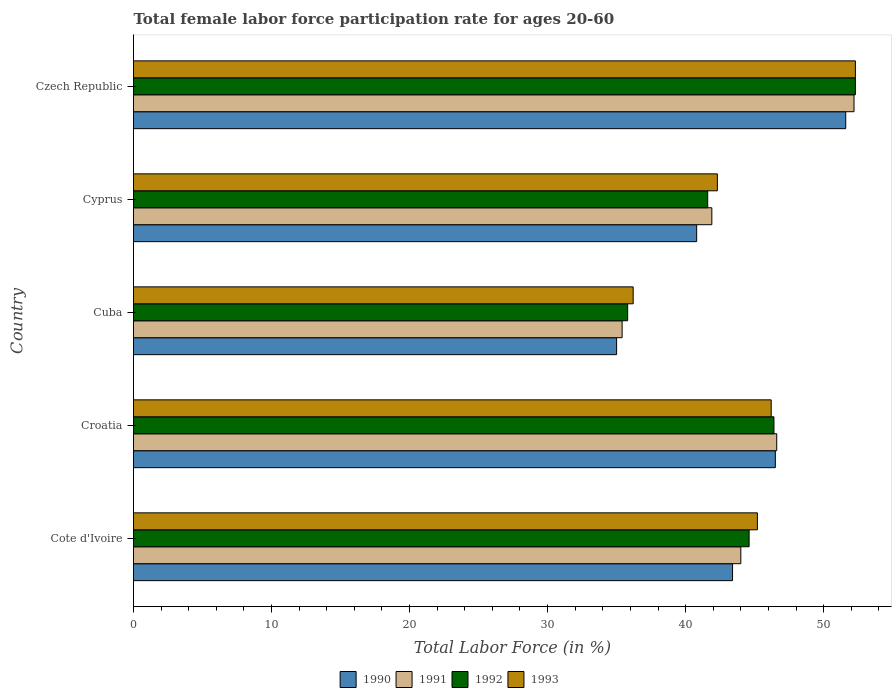How many different coloured bars are there?
Your answer should be compact. 4. How many groups of bars are there?
Give a very brief answer. 5. Are the number of bars on each tick of the Y-axis equal?
Your answer should be compact. Yes. How many bars are there on the 3rd tick from the bottom?
Give a very brief answer. 4. What is the label of the 3rd group of bars from the top?
Give a very brief answer. Cuba. In how many cases, is the number of bars for a given country not equal to the number of legend labels?
Your answer should be compact. 0. What is the female labor force participation rate in 1993 in Croatia?
Provide a succinct answer. 46.2. Across all countries, what is the maximum female labor force participation rate in 1993?
Ensure brevity in your answer.  52.3. Across all countries, what is the minimum female labor force participation rate in 1992?
Your response must be concise. 35.8. In which country was the female labor force participation rate in 1991 maximum?
Provide a succinct answer. Czech Republic. In which country was the female labor force participation rate in 1992 minimum?
Ensure brevity in your answer.  Cuba. What is the total female labor force participation rate in 1991 in the graph?
Your answer should be very brief. 220.1. What is the difference between the female labor force participation rate in 1991 in Cyprus and that in Czech Republic?
Offer a very short reply. -10.3. What is the difference between the female labor force participation rate in 1991 in Croatia and the female labor force participation rate in 1993 in Czech Republic?
Give a very brief answer. -5.7. What is the average female labor force participation rate in 1992 per country?
Provide a succinct answer. 44.14. What is the difference between the female labor force participation rate in 1993 and female labor force participation rate in 1990 in Croatia?
Offer a very short reply. -0.3. What is the ratio of the female labor force participation rate in 1993 in Cyprus to that in Czech Republic?
Give a very brief answer. 0.81. Is the female labor force participation rate in 1991 in Cuba less than that in Cyprus?
Keep it short and to the point. Yes. Is the difference between the female labor force participation rate in 1993 in Cote d'Ivoire and Cuba greater than the difference between the female labor force participation rate in 1990 in Cote d'Ivoire and Cuba?
Make the answer very short. Yes. What is the difference between the highest and the second highest female labor force participation rate in 1993?
Provide a succinct answer. 6.1. What is the difference between the highest and the lowest female labor force participation rate in 1993?
Your answer should be compact. 16.1. Is the sum of the female labor force participation rate in 1991 in Cyprus and Czech Republic greater than the maximum female labor force participation rate in 1993 across all countries?
Give a very brief answer. Yes. Is it the case that in every country, the sum of the female labor force participation rate in 1992 and female labor force participation rate in 1990 is greater than the sum of female labor force participation rate in 1991 and female labor force participation rate in 1993?
Your response must be concise. No. What does the 2nd bar from the bottom in Cyprus represents?
Provide a succinct answer. 1991. Is it the case that in every country, the sum of the female labor force participation rate in 1993 and female labor force participation rate in 1990 is greater than the female labor force participation rate in 1992?
Your response must be concise. Yes. How many bars are there?
Provide a succinct answer. 20. Are all the bars in the graph horizontal?
Keep it short and to the point. Yes. How many countries are there in the graph?
Provide a succinct answer. 5. What is the difference between two consecutive major ticks on the X-axis?
Your answer should be very brief. 10. Are the values on the major ticks of X-axis written in scientific E-notation?
Offer a very short reply. No. Does the graph contain grids?
Your response must be concise. No. Where does the legend appear in the graph?
Your answer should be very brief. Bottom center. How many legend labels are there?
Your answer should be compact. 4. How are the legend labels stacked?
Offer a terse response. Horizontal. What is the title of the graph?
Offer a terse response. Total female labor force participation rate for ages 20-60. What is the Total Labor Force (in %) of 1990 in Cote d'Ivoire?
Your answer should be compact. 43.4. What is the Total Labor Force (in %) in 1991 in Cote d'Ivoire?
Offer a terse response. 44. What is the Total Labor Force (in %) of 1992 in Cote d'Ivoire?
Your answer should be compact. 44.6. What is the Total Labor Force (in %) of 1993 in Cote d'Ivoire?
Give a very brief answer. 45.2. What is the Total Labor Force (in %) in 1990 in Croatia?
Ensure brevity in your answer.  46.5. What is the Total Labor Force (in %) of 1991 in Croatia?
Provide a succinct answer. 46.6. What is the Total Labor Force (in %) in 1992 in Croatia?
Ensure brevity in your answer.  46.4. What is the Total Labor Force (in %) of 1993 in Croatia?
Keep it short and to the point. 46.2. What is the Total Labor Force (in %) in 1990 in Cuba?
Your response must be concise. 35. What is the Total Labor Force (in %) in 1991 in Cuba?
Your answer should be compact. 35.4. What is the Total Labor Force (in %) in 1992 in Cuba?
Give a very brief answer. 35.8. What is the Total Labor Force (in %) in 1993 in Cuba?
Provide a short and direct response. 36.2. What is the Total Labor Force (in %) in 1990 in Cyprus?
Make the answer very short. 40.8. What is the Total Labor Force (in %) of 1991 in Cyprus?
Make the answer very short. 41.9. What is the Total Labor Force (in %) of 1992 in Cyprus?
Provide a short and direct response. 41.6. What is the Total Labor Force (in %) in 1993 in Cyprus?
Your response must be concise. 42.3. What is the Total Labor Force (in %) of 1990 in Czech Republic?
Your response must be concise. 51.6. What is the Total Labor Force (in %) in 1991 in Czech Republic?
Offer a very short reply. 52.2. What is the Total Labor Force (in %) of 1992 in Czech Republic?
Make the answer very short. 52.3. What is the Total Labor Force (in %) of 1993 in Czech Republic?
Keep it short and to the point. 52.3. Across all countries, what is the maximum Total Labor Force (in %) in 1990?
Make the answer very short. 51.6. Across all countries, what is the maximum Total Labor Force (in %) of 1991?
Give a very brief answer. 52.2. Across all countries, what is the maximum Total Labor Force (in %) in 1992?
Make the answer very short. 52.3. Across all countries, what is the maximum Total Labor Force (in %) in 1993?
Provide a short and direct response. 52.3. Across all countries, what is the minimum Total Labor Force (in %) of 1990?
Offer a terse response. 35. Across all countries, what is the minimum Total Labor Force (in %) in 1991?
Offer a very short reply. 35.4. Across all countries, what is the minimum Total Labor Force (in %) in 1992?
Offer a terse response. 35.8. Across all countries, what is the minimum Total Labor Force (in %) in 1993?
Your answer should be compact. 36.2. What is the total Total Labor Force (in %) in 1990 in the graph?
Keep it short and to the point. 217.3. What is the total Total Labor Force (in %) in 1991 in the graph?
Make the answer very short. 220.1. What is the total Total Labor Force (in %) of 1992 in the graph?
Give a very brief answer. 220.7. What is the total Total Labor Force (in %) in 1993 in the graph?
Provide a succinct answer. 222.2. What is the difference between the Total Labor Force (in %) of 1990 in Cote d'Ivoire and that in Croatia?
Ensure brevity in your answer.  -3.1. What is the difference between the Total Labor Force (in %) of 1991 in Cote d'Ivoire and that in Croatia?
Offer a terse response. -2.6. What is the difference between the Total Labor Force (in %) of 1992 in Cote d'Ivoire and that in Croatia?
Offer a very short reply. -1.8. What is the difference between the Total Labor Force (in %) in 1993 in Cote d'Ivoire and that in Croatia?
Offer a terse response. -1. What is the difference between the Total Labor Force (in %) in 1991 in Cote d'Ivoire and that in Cuba?
Give a very brief answer. 8.6. What is the difference between the Total Labor Force (in %) of 1993 in Cote d'Ivoire and that in Cuba?
Provide a short and direct response. 9. What is the difference between the Total Labor Force (in %) in 1990 in Cote d'Ivoire and that in Cyprus?
Your response must be concise. 2.6. What is the difference between the Total Labor Force (in %) of 1990 in Cote d'Ivoire and that in Czech Republic?
Keep it short and to the point. -8.2. What is the difference between the Total Labor Force (in %) in 1991 in Cote d'Ivoire and that in Czech Republic?
Your answer should be compact. -8.2. What is the difference between the Total Labor Force (in %) in 1991 in Croatia and that in Cuba?
Your answer should be compact. 11.2. What is the difference between the Total Labor Force (in %) of 1993 in Croatia and that in Cuba?
Your answer should be compact. 10. What is the difference between the Total Labor Force (in %) of 1990 in Croatia and that in Cyprus?
Provide a short and direct response. 5.7. What is the difference between the Total Labor Force (in %) in 1992 in Croatia and that in Cyprus?
Offer a terse response. 4.8. What is the difference between the Total Labor Force (in %) of 1993 in Croatia and that in Cyprus?
Your answer should be very brief. 3.9. What is the difference between the Total Labor Force (in %) of 1990 in Croatia and that in Czech Republic?
Your answer should be compact. -5.1. What is the difference between the Total Labor Force (in %) of 1992 in Croatia and that in Czech Republic?
Your answer should be compact. -5.9. What is the difference between the Total Labor Force (in %) in 1990 in Cuba and that in Cyprus?
Your answer should be compact. -5.8. What is the difference between the Total Labor Force (in %) in 1991 in Cuba and that in Cyprus?
Provide a short and direct response. -6.5. What is the difference between the Total Labor Force (in %) in 1993 in Cuba and that in Cyprus?
Your answer should be compact. -6.1. What is the difference between the Total Labor Force (in %) of 1990 in Cuba and that in Czech Republic?
Your answer should be compact. -16.6. What is the difference between the Total Labor Force (in %) in 1991 in Cuba and that in Czech Republic?
Provide a short and direct response. -16.8. What is the difference between the Total Labor Force (in %) in 1992 in Cuba and that in Czech Republic?
Offer a terse response. -16.5. What is the difference between the Total Labor Force (in %) of 1993 in Cuba and that in Czech Republic?
Keep it short and to the point. -16.1. What is the difference between the Total Labor Force (in %) in 1992 in Cyprus and that in Czech Republic?
Make the answer very short. -10.7. What is the difference between the Total Labor Force (in %) in 1990 in Cote d'Ivoire and the Total Labor Force (in %) in 1991 in Croatia?
Make the answer very short. -3.2. What is the difference between the Total Labor Force (in %) of 1990 in Cote d'Ivoire and the Total Labor Force (in %) of 1992 in Croatia?
Your response must be concise. -3. What is the difference between the Total Labor Force (in %) of 1990 in Cote d'Ivoire and the Total Labor Force (in %) of 1993 in Croatia?
Offer a very short reply. -2.8. What is the difference between the Total Labor Force (in %) of 1991 in Cote d'Ivoire and the Total Labor Force (in %) of 1992 in Croatia?
Give a very brief answer. -2.4. What is the difference between the Total Labor Force (in %) of 1992 in Cote d'Ivoire and the Total Labor Force (in %) of 1993 in Croatia?
Your answer should be very brief. -1.6. What is the difference between the Total Labor Force (in %) of 1990 in Cote d'Ivoire and the Total Labor Force (in %) of 1991 in Cuba?
Provide a short and direct response. 8. What is the difference between the Total Labor Force (in %) of 1990 in Cote d'Ivoire and the Total Labor Force (in %) of 1991 in Cyprus?
Offer a very short reply. 1.5. What is the difference between the Total Labor Force (in %) in 1990 in Cote d'Ivoire and the Total Labor Force (in %) in 1993 in Cyprus?
Provide a succinct answer. 1.1. What is the difference between the Total Labor Force (in %) of 1992 in Cote d'Ivoire and the Total Labor Force (in %) of 1993 in Cyprus?
Make the answer very short. 2.3. What is the difference between the Total Labor Force (in %) of 1990 in Cote d'Ivoire and the Total Labor Force (in %) of 1991 in Czech Republic?
Keep it short and to the point. -8.8. What is the difference between the Total Labor Force (in %) of 1990 in Cote d'Ivoire and the Total Labor Force (in %) of 1992 in Czech Republic?
Ensure brevity in your answer.  -8.9. What is the difference between the Total Labor Force (in %) in 1991 in Cote d'Ivoire and the Total Labor Force (in %) in 1992 in Czech Republic?
Your answer should be very brief. -8.3. What is the difference between the Total Labor Force (in %) of 1991 in Cote d'Ivoire and the Total Labor Force (in %) of 1993 in Czech Republic?
Ensure brevity in your answer.  -8.3. What is the difference between the Total Labor Force (in %) of 1990 in Croatia and the Total Labor Force (in %) of 1993 in Cuba?
Offer a terse response. 10.3. What is the difference between the Total Labor Force (in %) in 1991 in Croatia and the Total Labor Force (in %) in 1993 in Cuba?
Provide a short and direct response. 10.4. What is the difference between the Total Labor Force (in %) of 1992 in Croatia and the Total Labor Force (in %) of 1993 in Cuba?
Keep it short and to the point. 10.2. What is the difference between the Total Labor Force (in %) of 1990 in Croatia and the Total Labor Force (in %) of 1993 in Cyprus?
Your answer should be very brief. 4.2. What is the difference between the Total Labor Force (in %) in 1991 in Croatia and the Total Labor Force (in %) in 1993 in Cyprus?
Provide a succinct answer. 4.3. What is the difference between the Total Labor Force (in %) of 1990 in Croatia and the Total Labor Force (in %) of 1992 in Czech Republic?
Provide a short and direct response. -5.8. What is the difference between the Total Labor Force (in %) of 1990 in Cuba and the Total Labor Force (in %) of 1992 in Cyprus?
Your answer should be compact. -6.6. What is the difference between the Total Labor Force (in %) in 1992 in Cuba and the Total Labor Force (in %) in 1993 in Cyprus?
Keep it short and to the point. -6.5. What is the difference between the Total Labor Force (in %) of 1990 in Cuba and the Total Labor Force (in %) of 1991 in Czech Republic?
Provide a short and direct response. -17.2. What is the difference between the Total Labor Force (in %) of 1990 in Cuba and the Total Labor Force (in %) of 1992 in Czech Republic?
Your answer should be very brief. -17.3. What is the difference between the Total Labor Force (in %) of 1990 in Cuba and the Total Labor Force (in %) of 1993 in Czech Republic?
Your answer should be very brief. -17.3. What is the difference between the Total Labor Force (in %) of 1991 in Cuba and the Total Labor Force (in %) of 1992 in Czech Republic?
Your response must be concise. -16.9. What is the difference between the Total Labor Force (in %) of 1991 in Cuba and the Total Labor Force (in %) of 1993 in Czech Republic?
Keep it short and to the point. -16.9. What is the difference between the Total Labor Force (in %) in 1992 in Cuba and the Total Labor Force (in %) in 1993 in Czech Republic?
Keep it short and to the point. -16.5. What is the difference between the Total Labor Force (in %) of 1990 in Cyprus and the Total Labor Force (in %) of 1991 in Czech Republic?
Provide a succinct answer. -11.4. What is the difference between the Total Labor Force (in %) in 1990 in Cyprus and the Total Labor Force (in %) in 1993 in Czech Republic?
Your answer should be compact. -11.5. What is the average Total Labor Force (in %) of 1990 per country?
Your response must be concise. 43.46. What is the average Total Labor Force (in %) in 1991 per country?
Keep it short and to the point. 44.02. What is the average Total Labor Force (in %) of 1992 per country?
Provide a succinct answer. 44.14. What is the average Total Labor Force (in %) in 1993 per country?
Offer a terse response. 44.44. What is the difference between the Total Labor Force (in %) of 1990 and Total Labor Force (in %) of 1991 in Cote d'Ivoire?
Ensure brevity in your answer.  -0.6. What is the difference between the Total Labor Force (in %) in 1990 and Total Labor Force (in %) in 1992 in Cote d'Ivoire?
Provide a short and direct response. -1.2. What is the difference between the Total Labor Force (in %) in 1991 and Total Labor Force (in %) in 1992 in Cote d'Ivoire?
Provide a short and direct response. -0.6. What is the difference between the Total Labor Force (in %) of 1991 and Total Labor Force (in %) of 1993 in Cote d'Ivoire?
Make the answer very short. -1.2. What is the difference between the Total Labor Force (in %) in 1992 and Total Labor Force (in %) in 1993 in Cote d'Ivoire?
Ensure brevity in your answer.  -0.6. What is the difference between the Total Labor Force (in %) of 1990 and Total Labor Force (in %) of 1991 in Croatia?
Offer a very short reply. -0.1. What is the difference between the Total Labor Force (in %) of 1990 and Total Labor Force (in %) of 1992 in Croatia?
Offer a terse response. 0.1. What is the difference between the Total Labor Force (in %) in 1990 and Total Labor Force (in %) in 1993 in Croatia?
Make the answer very short. 0.3. What is the difference between the Total Labor Force (in %) in 1991 and Total Labor Force (in %) in 1992 in Croatia?
Your answer should be very brief. 0.2. What is the difference between the Total Labor Force (in %) in 1991 and Total Labor Force (in %) in 1993 in Croatia?
Make the answer very short. 0.4. What is the difference between the Total Labor Force (in %) of 1992 and Total Labor Force (in %) of 1993 in Croatia?
Your answer should be very brief. 0.2. What is the difference between the Total Labor Force (in %) of 1990 and Total Labor Force (in %) of 1992 in Cuba?
Keep it short and to the point. -0.8. What is the difference between the Total Labor Force (in %) of 1990 and Total Labor Force (in %) of 1993 in Cuba?
Your answer should be compact. -1.2. What is the difference between the Total Labor Force (in %) of 1991 and Total Labor Force (in %) of 1992 in Cuba?
Keep it short and to the point. -0.4. What is the difference between the Total Labor Force (in %) of 1992 and Total Labor Force (in %) of 1993 in Cuba?
Provide a short and direct response. -0.4. What is the difference between the Total Labor Force (in %) of 1990 and Total Labor Force (in %) of 1992 in Cyprus?
Your answer should be very brief. -0.8. What is the difference between the Total Labor Force (in %) of 1990 and Total Labor Force (in %) of 1993 in Cyprus?
Your answer should be very brief. -1.5. What is the difference between the Total Labor Force (in %) of 1990 and Total Labor Force (in %) of 1991 in Czech Republic?
Make the answer very short. -0.6. What is the difference between the Total Labor Force (in %) of 1991 and Total Labor Force (in %) of 1992 in Czech Republic?
Give a very brief answer. -0.1. What is the difference between the Total Labor Force (in %) in 1992 and Total Labor Force (in %) in 1993 in Czech Republic?
Offer a terse response. 0. What is the ratio of the Total Labor Force (in %) in 1991 in Cote d'Ivoire to that in Croatia?
Provide a short and direct response. 0.94. What is the ratio of the Total Labor Force (in %) in 1992 in Cote d'Ivoire to that in Croatia?
Offer a very short reply. 0.96. What is the ratio of the Total Labor Force (in %) of 1993 in Cote d'Ivoire to that in Croatia?
Keep it short and to the point. 0.98. What is the ratio of the Total Labor Force (in %) in 1990 in Cote d'Ivoire to that in Cuba?
Ensure brevity in your answer.  1.24. What is the ratio of the Total Labor Force (in %) in 1991 in Cote d'Ivoire to that in Cuba?
Your response must be concise. 1.24. What is the ratio of the Total Labor Force (in %) of 1992 in Cote d'Ivoire to that in Cuba?
Your response must be concise. 1.25. What is the ratio of the Total Labor Force (in %) in 1993 in Cote d'Ivoire to that in Cuba?
Provide a succinct answer. 1.25. What is the ratio of the Total Labor Force (in %) of 1990 in Cote d'Ivoire to that in Cyprus?
Offer a very short reply. 1.06. What is the ratio of the Total Labor Force (in %) in 1991 in Cote d'Ivoire to that in Cyprus?
Ensure brevity in your answer.  1.05. What is the ratio of the Total Labor Force (in %) in 1992 in Cote d'Ivoire to that in Cyprus?
Your answer should be compact. 1.07. What is the ratio of the Total Labor Force (in %) in 1993 in Cote d'Ivoire to that in Cyprus?
Your answer should be very brief. 1.07. What is the ratio of the Total Labor Force (in %) in 1990 in Cote d'Ivoire to that in Czech Republic?
Ensure brevity in your answer.  0.84. What is the ratio of the Total Labor Force (in %) in 1991 in Cote d'Ivoire to that in Czech Republic?
Make the answer very short. 0.84. What is the ratio of the Total Labor Force (in %) in 1992 in Cote d'Ivoire to that in Czech Republic?
Your answer should be compact. 0.85. What is the ratio of the Total Labor Force (in %) of 1993 in Cote d'Ivoire to that in Czech Republic?
Your answer should be very brief. 0.86. What is the ratio of the Total Labor Force (in %) of 1990 in Croatia to that in Cuba?
Your answer should be very brief. 1.33. What is the ratio of the Total Labor Force (in %) of 1991 in Croatia to that in Cuba?
Ensure brevity in your answer.  1.32. What is the ratio of the Total Labor Force (in %) in 1992 in Croatia to that in Cuba?
Give a very brief answer. 1.3. What is the ratio of the Total Labor Force (in %) in 1993 in Croatia to that in Cuba?
Your answer should be compact. 1.28. What is the ratio of the Total Labor Force (in %) of 1990 in Croatia to that in Cyprus?
Provide a short and direct response. 1.14. What is the ratio of the Total Labor Force (in %) of 1991 in Croatia to that in Cyprus?
Provide a short and direct response. 1.11. What is the ratio of the Total Labor Force (in %) in 1992 in Croatia to that in Cyprus?
Keep it short and to the point. 1.12. What is the ratio of the Total Labor Force (in %) of 1993 in Croatia to that in Cyprus?
Keep it short and to the point. 1.09. What is the ratio of the Total Labor Force (in %) in 1990 in Croatia to that in Czech Republic?
Your answer should be compact. 0.9. What is the ratio of the Total Labor Force (in %) in 1991 in Croatia to that in Czech Republic?
Ensure brevity in your answer.  0.89. What is the ratio of the Total Labor Force (in %) of 1992 in Croatia to that in Czech Republic?
Your answer should be compact. 0.89. What is the ratio of the Total Labor Force (in %) of 1993 in Croatia to that in Czech Republic?
Your answer should be compact. 0.88. What is the ratio of the Total Labor Force (in %) in 1990 in Cuba to that in Cyprus?
Your response must be concise. 0.86. What is the ratio of the Total Labor Force (in %) of 1991 in Cuba to that in Cyprus?
Provide a succinct answer. 0.84. What is the ratio of the Total Labor Force (in %) in 1992 in Cuba to that in Cyprus?
Give a very brief answer. 0.86. What is the ratio of the Total Labor Force (in %) in 1993 in Cuba to that in Cyprus?
Your answer should be very brief. 0.86. What is the ratio of the Total Labor Force (in %) in 1990 in Cuba to that in Czech Republic?
Offer a very short reply. 0.68. What is the ratio of the Total Labor Force (in %) in 1991 in Cuba to that in Czech Republic?
Your answer should be very brief. 0.68. What is the ratio of the Total Labor Force (in %) of 1992 in Cuba to that in Czech Republic?
Your answer should be very brief. 0.68. What is the ratio of the Total Labor Force (in %) in 1993 in Cuba to that in Czech Republic?
Keep it short and to the point. 0.69. What is the ratio of the Total Labor Force (in %) in 1990 in Cyprus to that in Czech Republic?
Provide a short and direct response. 0.79. What is the ratio of the Total Labor Force (in %) in 1991 in Cyprus to that in Czech Republic?
Your answer should be compact. 0.8. What is the ratio of the Total Labor Force (in %) of 1992 in Cyprus to that in Czech Republic?
Keep it short and to the point. 0.8. What is the ratio of the Total Labor Force (in %) in 1993 in Cyprus to that in Czech Republic?
Ensure brevity in your answer.  0.81. What is the difference between the highest and the second highest Total Labor Force (in %) in 1992?
Your response must be concise. 5.9. What is the difference between the highest and the second highest Total Labor Force (in %) in 1993?
Give a very brief answer. 6.1. What is the difference between the highest and the lowest Total Labor Force (in %) in 1990?
Make the answer very short. 16.6. 